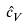Convert formula to latex. <formula><loc_0><loc_0><loc_500><loc_500>\hat { c } _ { V }</formula> 